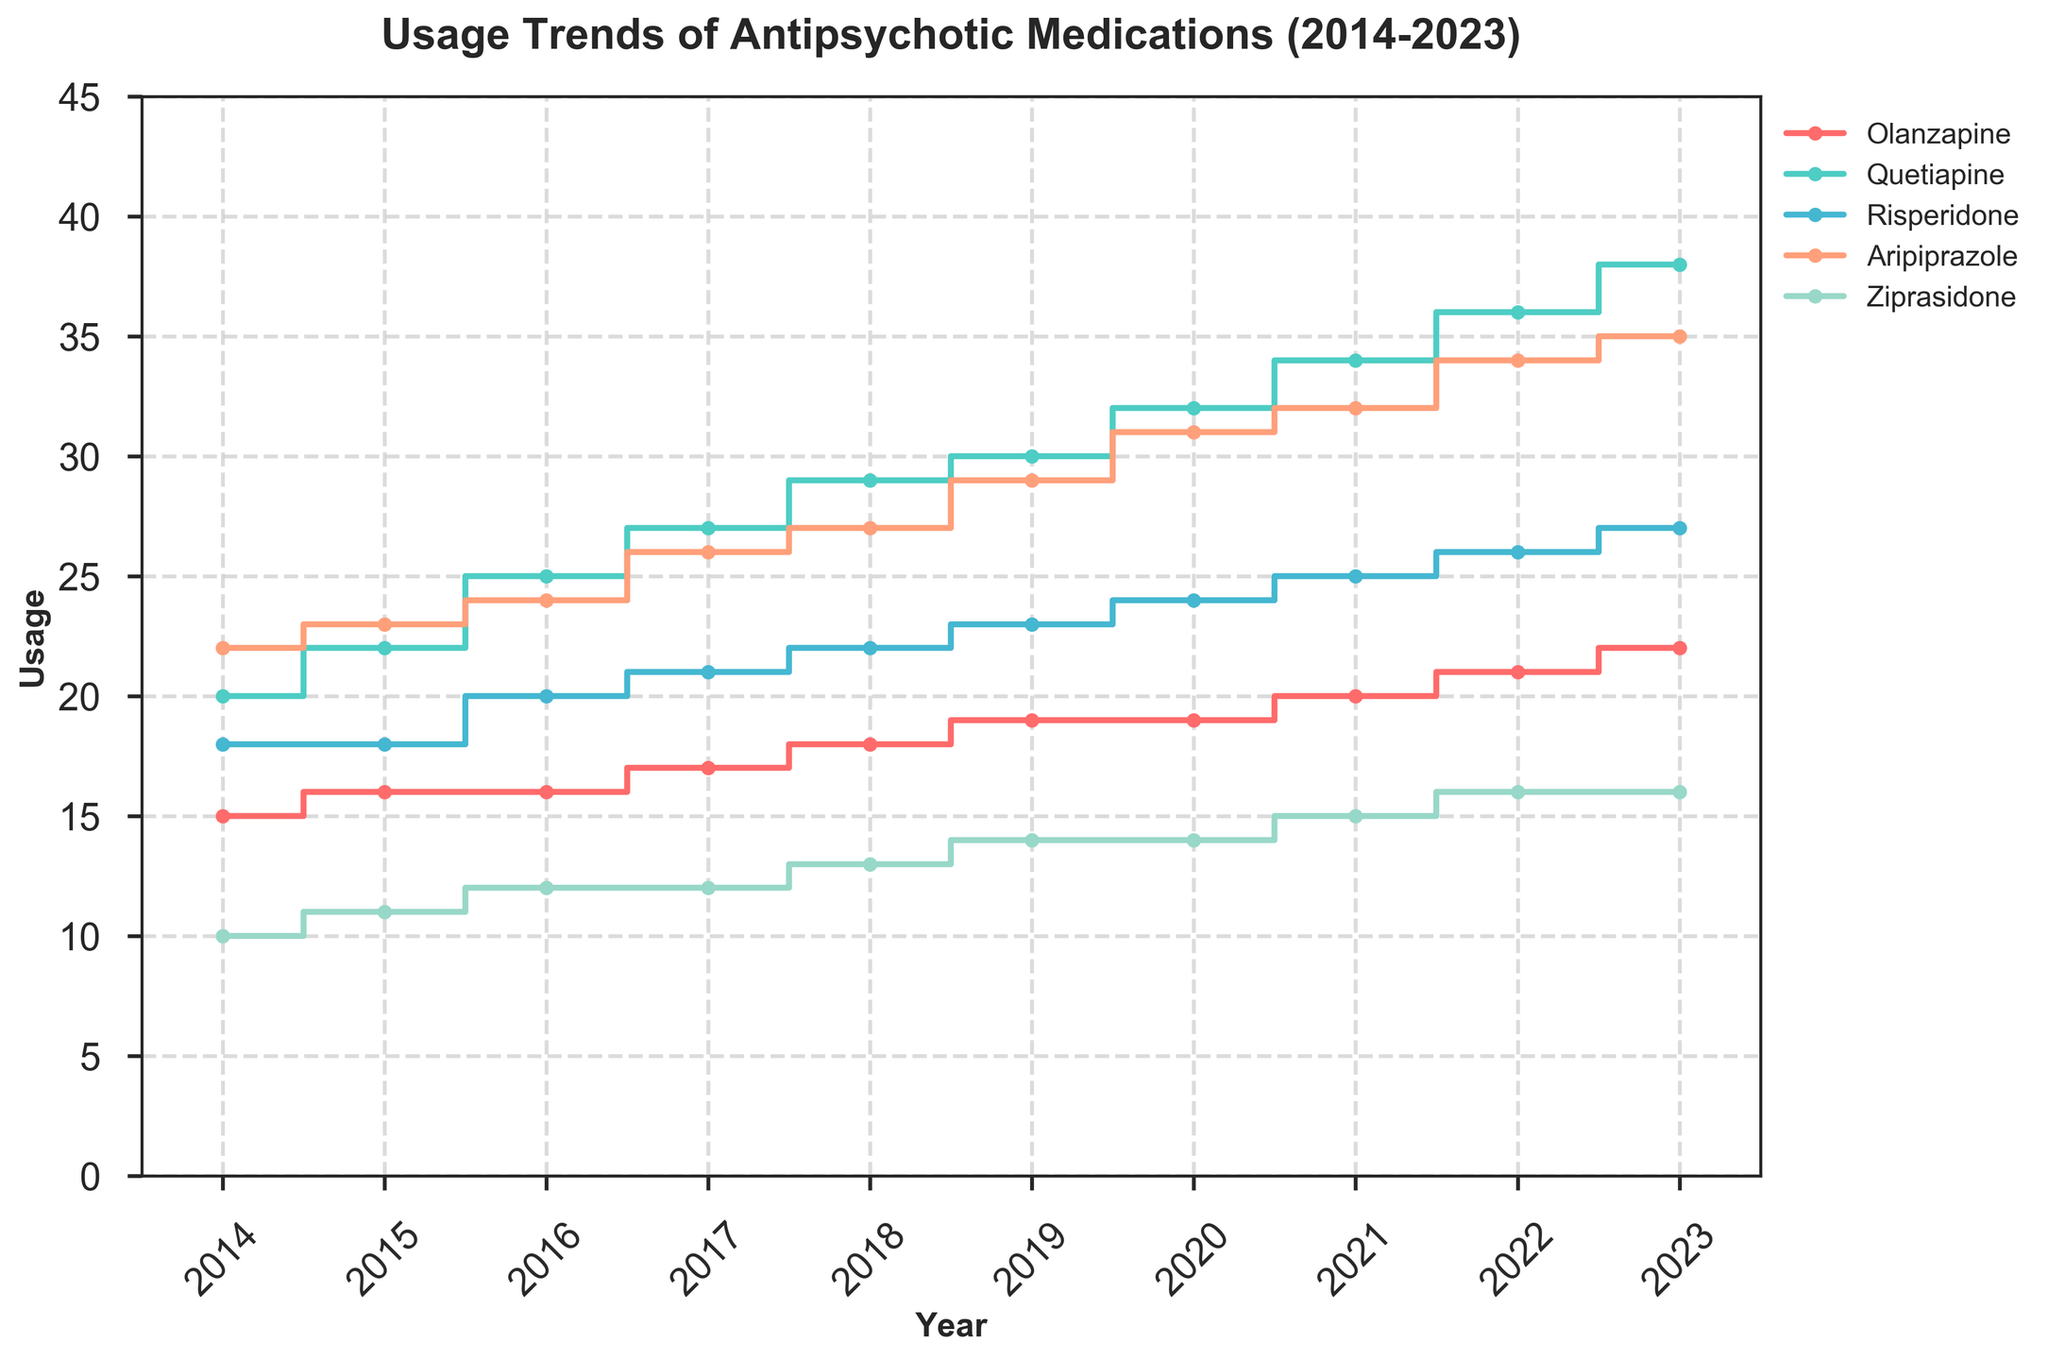What is the title of the figure? The title is displayed at the top of the figure in bold text.
Answer: Usage Trends of Antipsychotic Medications (2014-2023) How many types of antipsychotic medications are shown in the figure? There are five different colored lines, each representing a different medication.
Answer: Five Which medication had the highest usage in 2023? By examining the endpoints of each stair plot line, the line for Quetiapine reaches the highest value in 2023.
Answer: Quetiapine What is the usage trend for Ziprasidone from 2014 to 2023? Observing the Ziprasidone stair plot line, it starts at 10 in 2014 and ends consistently at 16 from 2022 to 2023, showing a gradual increase over the years.
Answer: Gradual increase Between which two years did Olanzapine see the largest increase in usage? Comparing the steps in the stair plot for Olanzapine, the largest jump occurs between 2022 and 2023 where it increases from 21 to 22.
Answer: 2022 to 2023 What is the total increase in usage of Aripiprazole from 2014 to 2023? Subtract the starting value from the ending value for Aripiprazole: 35 - 22 = 13.
Answer: 13 Which medication had the smallest change in usage over the decade? Comparing the starting and ending values of the stair plots for each medication, Risperidone shows an increase from 18 to 27, the smallest relative change.
Answer: Risperidone In which year did Quetiapine usage equal 25? Looking at the stair plot for Quetiapine, it reaches the value 25 in 2016.
Answer: 2016 How does the trend of Quetiapine compare to that of Risperidone over the decade? Comparing the stair plots, Quetiapine shows a steeper upward trend than Risperidone, indicating a faster increase in usage.
Answer: Faster increase What is the average usage of Olanzapine over the decade? Adding the yearly values for Olanzapine (15+16+16+17+18+19+19+20+21+22) and dividing by 10 gives the average as 183/10 = 18.3.
Answer: 18.3 